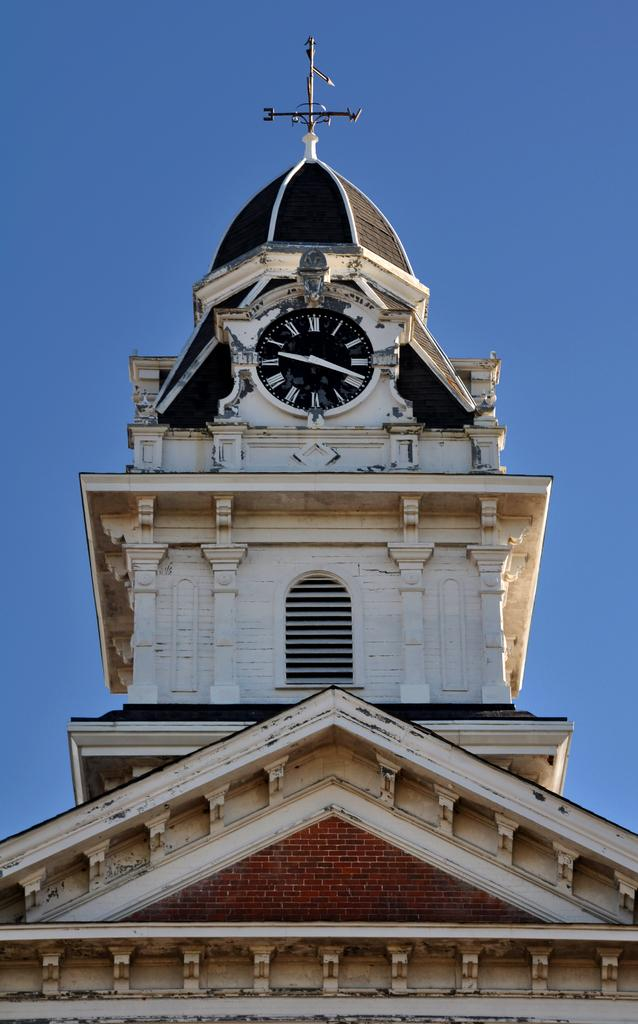What is the main structure in the foreground of the picture? There is a building in the foreground of the picture. What object is located in the center of the picture? There is a clock in the center of the picture. What navigational tool is present at the top of the picture? There is a compass at the top of the picture. What can be seen in the background of the picture? The sky is visible in the background of the picture. What color are the mother's toes in the image? There is no mother or reference to toes in the image; it features a building, clock, and compass. 